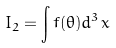<formula> <loc_0><loc_0><loc_500><loc_500>I _ { 2 } = \int f ( \theta ) d ^ { 3 } x</formula> 